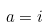<formula> <loc_0><loc_0><loc_500><loc_500>a = i</formula> 